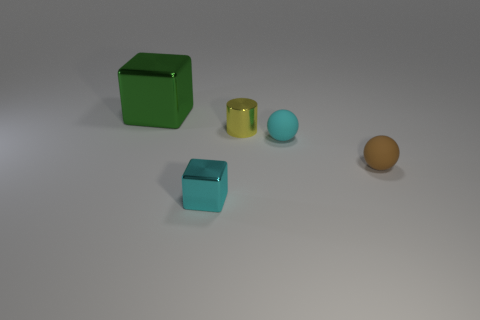What is the color of the rubber sphere on the left side of the matte ball that is right of the tiny cyan rubber thing?
Offer a very short reply. Cyan. How many tiny purple balls are there?
Give a very brief answer. 0. How many metal things are small cyan cubes or cyan spheres?
Make the answer very short. 1. How many tiny matte objects have the same color as the small metal block?
Provide a succinct answer. 1. What is the material of the large block on the left side of the block that is in front of the small yellow metal cylinder?
Provide a short and direct response. Metal. What is the size of the green metallic block?
Your answer should be very brief. Large. How many green metal cubes are the same size as the green object?
Your answer should be compact. 0. How many purple matte objects are the same shape as the cyan rubber object?
Give a very brief answer. 0. Are there an equal number of cyan balls that are to the left of the green metal thing and small red matte cubes?
Provide a short and direct response. Yes. Is there anything else that has the same size as the green metal thing?
Offer a very short reply. No. 